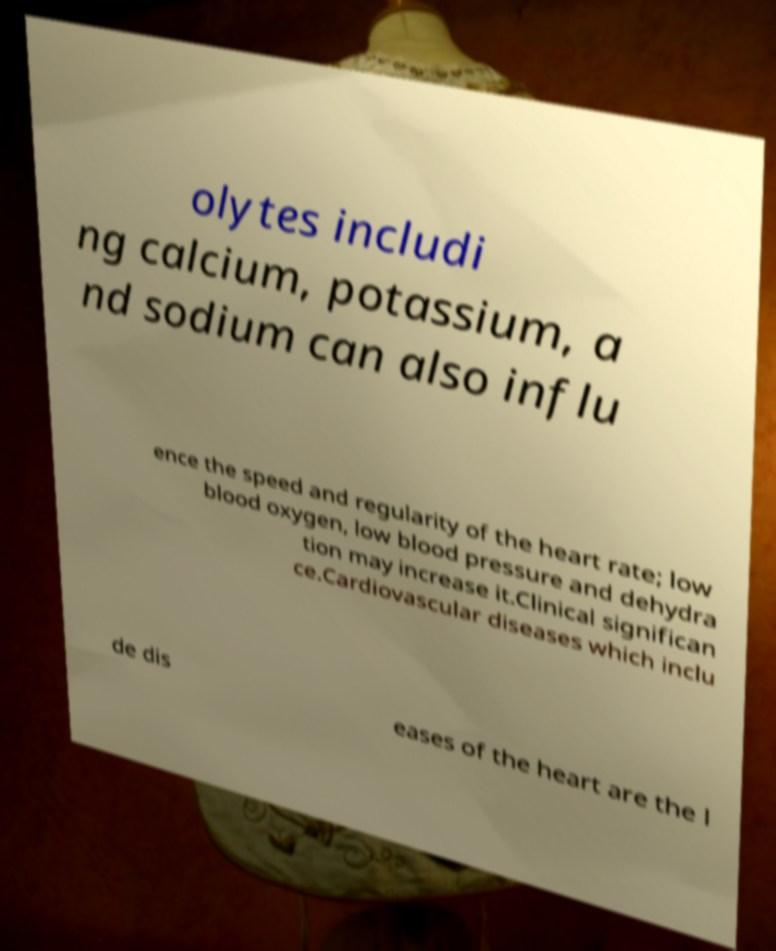Can you accurately transcribe the text from the provided image for me? olytes includi ng calcium, potassium, a nd sodium can also influ ence the speed and regularity of the heart rate; low blood oxygen, low blood pressure and dehydra tion may increase it.Clinical significan ce.Cardiovascular diseases which inclu de dis eases of the heart are the l 